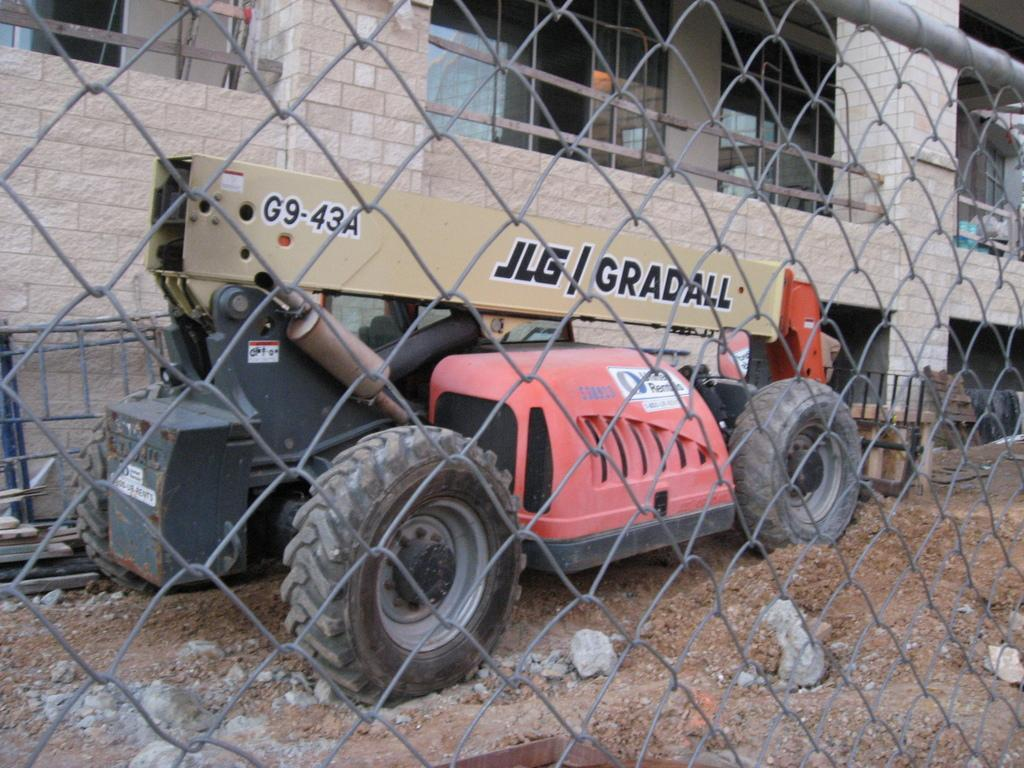What type of barrier can be seen in the image? There is a fence in the image. What is parked in the image? A vehicle is parked in the image. What type of material is present in the image? There are stones in the image. What other structure made of stones can be seen in the image? There is a stone wall in the image. What type of doors are visible in the background of the image? Glass doors are visible in the background of the image. What type of apparel is being worn by the waves in the image? There are no waves present in the image, and therefore no apparel can be associated with them. How many hills can be seen in the image? There are no hills present in the image. 